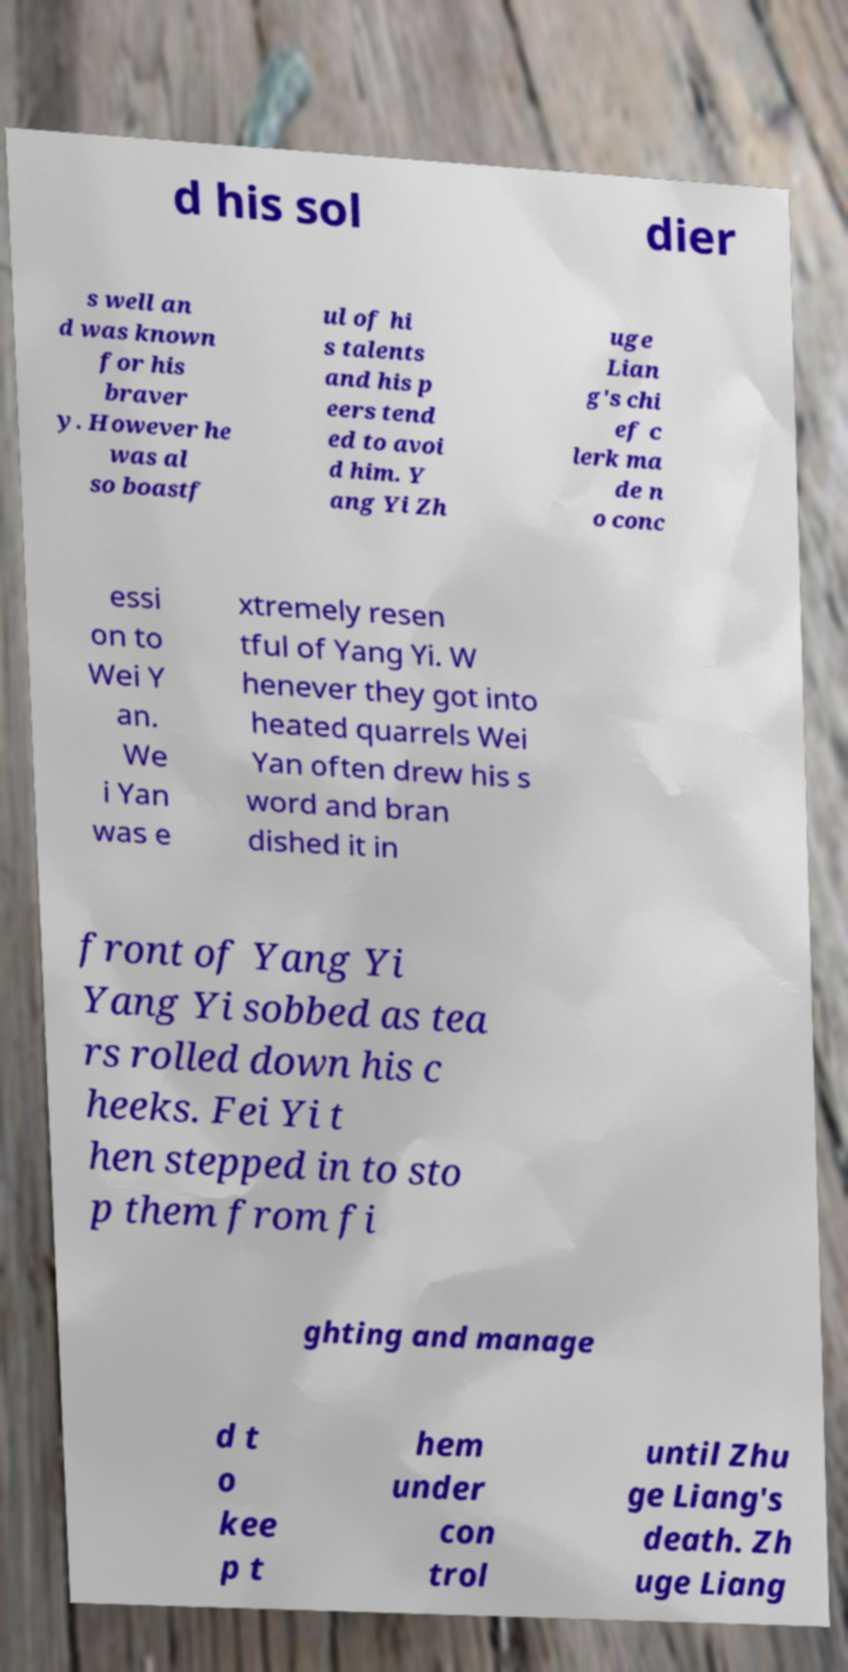Please identify and transcribe the text found in this image. d his sol dier s well an d was known for his braver y. However he was al so boastf ul of hi s talents and his p eers tend ed to avoi d him. Y ang Yi Zh uge Lian g's chi ef c lerk ma de n o conc essi on to Wei Y an. We i Yan was e xtremely resen tful of Yang Yi. W henever they got into heated quarrels Wei Yan often drew his s word and bran dished it in front of Yang Yi Yang Yi sobbed as tea rs rolled down his c heeks. Fei Yi t hen stepped in to sto p them from fi ghting and manage d t o kee p t hem under con trol until Zhu ge Liang's death. Zh uge Liang 